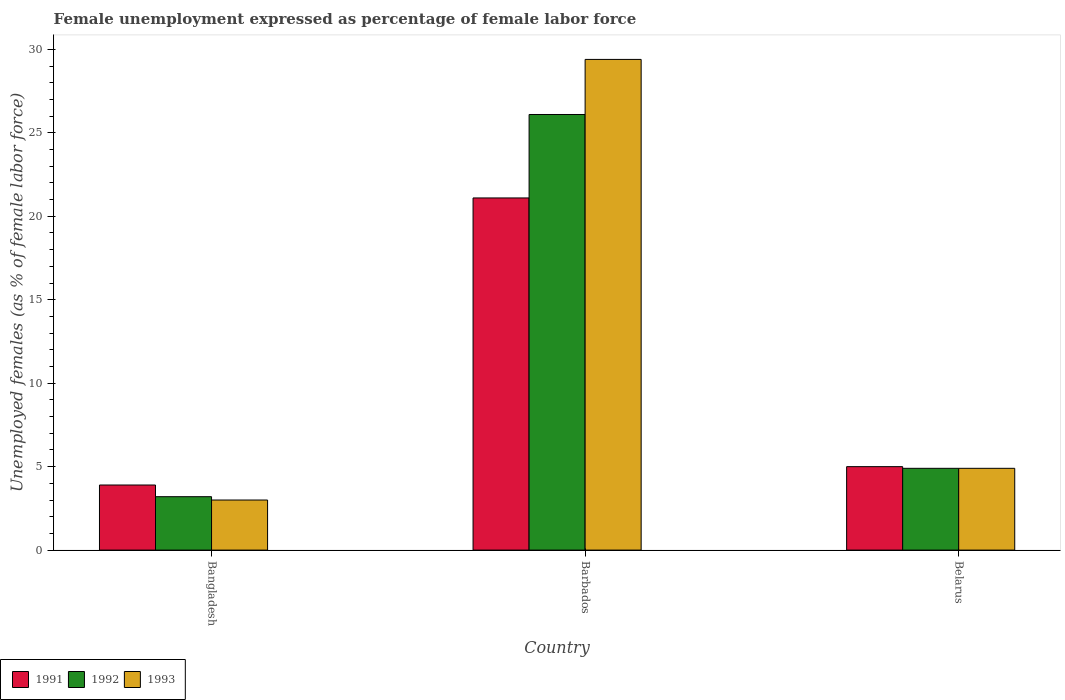Are the number of bars on each tick of the X-axis equal?
Your answer should be compact. Yes. How many bars are there on the 3rd tick from the right?
Ensure brevity in your answer.  3. What is the label of the 2nd group of bars from the left?
Make the answer very short. Barbados. What is the unemployment in females in in 1993 in Barbados?
Provide a short and direct response. 29.4. Across all countries, what is the maximum unemployment in females in in 1992?
Ensure brevity in your answer.  26.1. Across all countries, what is the minimum unemployment in females in in 1991?
Provide a succinct answer. 3.9. In which country was the unemployment in females in in 1993 maximum?
Your response must be concise. Barbados. In which country was the unemployment in females in in 1991 minimum?
Provide a short and direct response. Bangladesh. What is the total unemployment in females in in 1993 in the graph?
Your response must be concise. 37.3. What is the difference between the unemployment in females in in 1992 in Bangladesh and that in Barbados?
Your response must be concise. -22.9. What is the difference between the unemployment in females in in 1992 in Bangladesh and the unemployment in females in in 1991 in Belarus?
Keep it short and to the point. -1.8. What is the average unemployment in females in in 1991 per country?
Give a very brief answer. 10. What is the difference between the unemployment in females in of/in 1991 and unemployment in females in of/in 1993 in Bangladesh?
Offer a terse response. 0.9. What is the ratio of the unemployment in females in in 1993 in Bangladesh to that in Belarus?
Your answer should be very brief. 0.61. Is the difference between the unemployment in females in in 1991 in Barbados and Belarus greater than the difference between the unemployment in females in in 1993 in Barbados and Belarus?
Offer a very short reply. No. What is the difference between the highest and the second highest unemployment in females in in 1991?
Ensure brevity in your answer.  1.1. What is the difference between the highest and the lowest unemployment in females in in 1992?
Your response must be concise. 22.9. In how many countries, is the unemployment in females in in 1992 greater than the average unemployment in females in in 1992 taken over all countries?
Your answer should be compact. 1. Is the sum of the unemployment in females in in 1991 in Barbados and Belarus greater than the maximum unemployment in females in in 1993 across all countries?
Provide a short and direct response. No. What does the 2nd bar from the left in Bangladesh represents?
Make the answer very short. 1992. How many bars are there?
Your response must be concise. 9. What is the difference between two consecutive major ticks on the Y-axis?
Offer a terse response. 5. Does the graph contain grids?
Give a very brief answer. No. How many legend labels are there?
Offer a very short reply. 3. How are the legend labels stacked?
Provide a short and direct response. Horizontal. What is the title of the graph?
Provide a succinct answer. Female unemployment expressed as percentage of female labor force. What is the label or title of the X-axis?
Provide a short and direct response. Country. What is the label or title of the Y-axis?
Your answer should be compact. Unemployed females (as % of female labor force). What is the Unemployed females (as % of female labor force) in 1991 in Bangladesh?
Offer a very short reply. 3.9. What is the Unemployed females (as % of female labor force) in 1992 in Bangladesh?
Offer a terse response. 3.2. What is the Unemployed females (as % of female labor force) in 1993 in Bangladesh?
Provide a short and direct response. 3. What is the Unemployed females (as % of female labor force) of 1991 in Barbados?
Your answer should be very brief. 21.1. What is the Unemployed females (as % of female labor force) in 1992 in Barbados?
Your response must be concise. 26.1. What is the Unemployed females (as % of female labor force) of 1993 in Barbados?
Provide a short and direct response. 29.4. What is the Unemployed females (as % of female labor force) in 1991 in Belarus?
Make the answer very short. 5. What is the Unemployed females (as % of female labor force) of 1992 in Belarus?
Offer a terse response. 4.9. What is the Unemployed females (as % of female labor force) in 1993 in Belarus?
Your response must be concise. 4.9. Across all countries, what is the maximum Unemployed females (as % of female labor force) of 1991?
Make the answer very short. 21.1. Across all countries, what is the maximum Unemployed females (as % of female labor force) of 1992?
Provide a succinct answer. 26.1. Across all countries, what is the maximum Unemployed females (as % of female labor force) of 1993?
Offer a terse response. 29.4. Across all countries, what is the minimum Unemployed females (as % of female labor force) in 1991?
Your answer should be very brief. 3.9. Across all countries, what is the minimum Unemployed females (as % of female labor force) in 1992?
Offer a very short reply. 3.2. What is the total Unemployed females (as % of female labor force) in 1992 in the graph?
Offer a very short reply. 34.2. What is the total Unemployed females (as % of female labor force) in 1993 in the graph?
Give a very brief answer. 37.3. What is the difference between the Unemployed females (as % of female labor force) in 1991 in Bangladesh and that in Barbados?
Offer a terse response. -17.2. What is the difference between the Unemployed females (as % of female labor force) in 1992 in Bangladesh and that in Barbados?
Your response must be concise. -22.9. What is the difference between the Unemployed females (as % of female labor force) of 1993 in Bangladesh and that in Barbados?
Give a very brief answer. -26.4. What is the difference between the Unemployed females (as % of female labor force) of 1991 in Bangladesh and that in Belarus?
Give a very brief answer. -1.1. What is the difference between the Unemployed females (as % of female labor force) of 1993 in Bangladesh and that in Belarus?
Your response must be concise. -1.9. What is the difference between the Unemployed females (as % of female labor force) in 1992 in Barbados and that in Belarus?
Make the answer very short. 21.2. What is the difference between the Unemployed females (as % of female labor force) of 1991 in Bangladesh and the Unemployed females (as % of female labor force) of 1992 in Barbados?
Your response must be concise. -22.2. What is the difference between the Unemployed females (as % of female labor force) of 1991 in Bangladesh and the Unemployed females (as % of female labor force) of 1993 in Barbados?
Offer a terse response. -25.5. What is the difference between the Unemployed females (as % of female labor force) in 1992 in Bangladesh and the Unemployed females (as % of female labor force) in 1993 in Barbados?
Keep it short and to the point. -26.2. What is the difference between the Unemployed females (as % of female labor force) of 1991 in Bangladesh and the Unemployed females (as % of female labor force) of 1992 in Belarus?
Give a very brief answer. -1. What is the difference between the Unemployed females (as % of female labor force) in 1991 in Bangladesh and the Unemployed females (as % of female labor force) in 1993 in Belarus?
Your answer should be compact. -1. What is the difference between the Unemployed females (as % of female labor force) of 1992 in Barbados and the Unemployed females (as % of female labor force) of 1993 in Belarus?
Keep it short and to the point. 21.2. What is the average Unemployed females (as % of female labor force) in 1991 per country?
Your answer should be very brief. 10. What is the average Unemployed females (as % of female labor force) in 1992 per country?
Provide a succinct answer. 11.4. What is the average Unemployed females (as % of female labor force) of 1993 per country?
Provide a short and direct response. 12.43. What is the difference between the Unemployed females (as % of female labor force) of 1991 and Unemployed females (as % of female labor force) of 1992 in Bangladesh?
Your response must be concise. 0.7. What is the difference between the Unemployed females (as % of female labor force) of 1991 and Unemployed females (as % of female labor force) of 1993 in Bangladesh?
Give a very brief answer. 0.9. What is the difference between the Unemployed females (as % of female labor force) of 1992 and Unemployed females (as % of female labor force) of 1993 in Bangladesh?
Make the answer very short. 0.2. What is the difference between the Unemployed females (as % of female labor force) in 1992 and Unemployed females (as % of female labor force) in 1993 in Barbados?
Offer a very short reply. -3.3. What is the difference between the Unemployed females (as % of female labor force) of 1991 and Unemployed females (as % of female labor force) of 1992 in Belarus?
Ensure brevity in your answer.  0.1. What is the difference between the Unemployed females (as % of female labor force) in 1992 and Unemployed females (as % of female labor force) in 1993 in Belarus?
Give a very brief answer. 0. What is the ratio of the Unemployed females (as % of female labor force) in 1991 in Bangladesh to that in Barbados?
Your response must be concise. 0.18. What is the ratio of the Unemployed females (as % of female labor force) of 1992 in Bangladesh to that in Barbados?
Provide a succinct answer. 0.12. What is the ratio of the Unemployed females (as % of female labor force) of 1993 in Bangladesh to that in Barbados?
Offer a very short reply. 0.1. What is the ratio of the Unemployed females (as % of female labor force) in 1991 in Bangladesh to that in Belarus?
Your answer should be very brief. 0.78. What is the ratio of the Unemployed females (as % of female labor force) in 1992 in Bangladesh to that in Belarus?
Your answer should be compact. 0.65. What is the ratio of the Unemployed females (as % of female labor force) in 1993 in Bangladesh to that in Belarus?
Offer a terse response. 0.61. What is the ratio of the Unemployed females (as % of female labor force) in 1991 in Barbados to that in Belarus?
Offer a very short reply. 4.22. What is the ratio of the Unemployed females (as % of female labor force) of 1992 in Barbados to that in Belarus?
Your answer should be compact. 5.33. What is the difference between the highest and the second highest Unemployed females (as % of female labor force) of 1992?
Give a very brief answer. 21.2. What is the difference between the highest and the lowest Unemployed females (as % of female labor force) in 1991?
Keep it short and to the point. 17.2. What is the difference between the highest and the lowest Unemployed females (as % of female labor force) in 1992?
Make the answer very short. 22.9. What is the difference between the highest and the lowest Unemployed females (as % of female labor force) in 1993?
Ensure brevity in your answer.  26.4. 